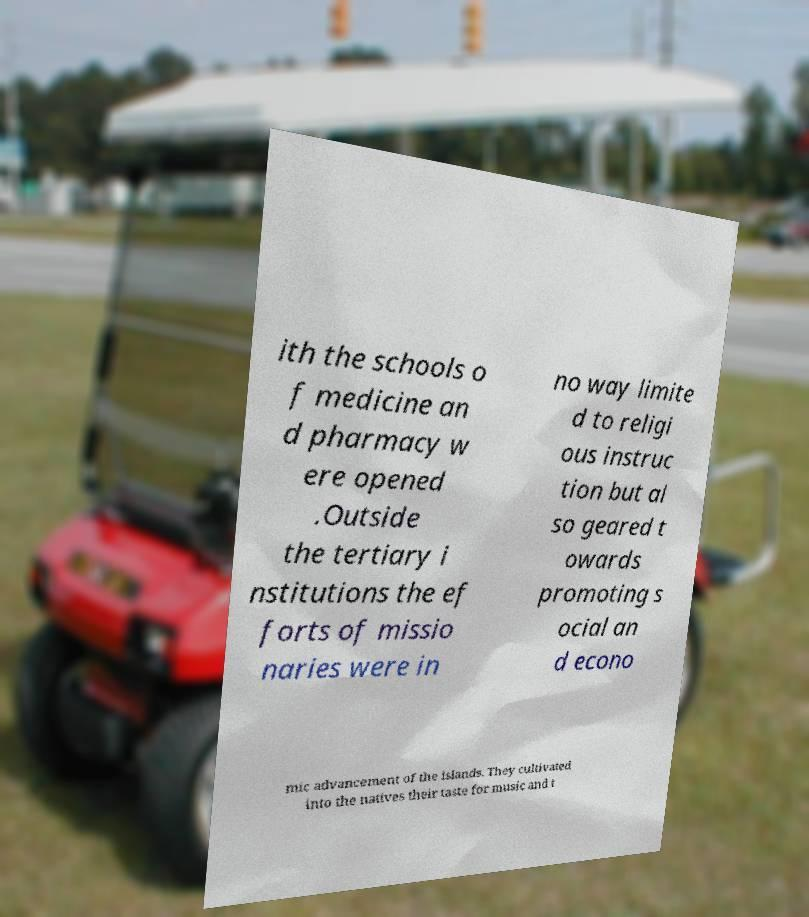I need the written content from this picture converted into text. Can you do that? ith the schools o f medicine an d pharmacy w ere opened .Outside the tertiary i nstitutions the ef forts of missio naries were in no way limite d to religi ous instruc tion but al so geared t owards promoting s ocial an d econo mic advancement of the islands. They cultivated into the natives their taste for music and t 